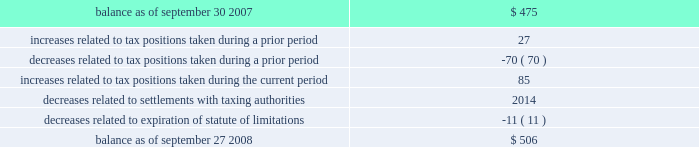Table of contents notes to consolidated financial statements ( continued ) note 5 2014income taxes ( continued ) fin 48 in the first quarter of 2008 , the company adopted fin 48 .
Upon adoption of fin 48 , the company 2019s cumulative effect of a change in accounting principle resulted in an increase to retained earnings of $ 11 million .
The company had historically classified interest and penalties and unrecognized tax benefits as current liabilities .
Beginning with the adoption of fin 48 , the company classifies gross interest and penalties and unrecognized tax benefits that are not expected to result in payment or receipt of cash within one year as non-current liabilities in the consolidated balance sheet .
The total amount of gross unrecognized tax benefits as of the date of adoption of fin 48 was $ 475 million , of which $ 209 million , if recognized , would affect the company 2019s effective tax rate .
As of september 27 , 2008 , the total amount of gross unrecognized tax benefits was $ 506 million , of which $ 253 million , if recognized , would affect the company 2019s effective tax rate .
The company 2019s total gross unrecognized tax benefits are classified as non-current liabilities in the consolidated balance sheet .
The aggregate changes in the balance of gross unrecognized tax benefits , which excludes interest and penalties , for the fiscal year ended september 27 , 2008 , is as follows ( in millions ) : the company 2019s policy to include interest and penalties related to unrecognized tax benefits within the provision for income taxes did not change as a result of adopting fin 48 .
As of the date of adoption , the company had accrued $ 203 million for the gross interest and penalties relating to unrecognized tax benefits .
As of september 27 , 2008 , the total amount of gross interest and penalties accrued was $ 219 million , which is classified as non-current liabilities in the consolidated balance sheet .
In 2008 , the company recognized interest expense in connection with tax matters of $ 16 million .
The company is subject to taxation and files income tax returns in the u.s .
Federal jurisdiction and in many state and foreign jurisdictions .
For u.s .
Federal income tax purposes , all years prior to 2002 are closed .
The years 2002-2003 have been examined by the internal revenue service ( the 201cirs 201d ) and disputed issues have been taken to administrative appeals .
The irs is currently examining the 2004-2006 years .
In addition , the company is also subject to audits by state , local , and foreign tax authorities .
In major states and major foreign jurisdictions , the years subsequent to 1988 and 2000 , respectively , generally remain open and could be subject to examination by the taxing authorities .
Management believes that an adequate provision has been made for any adjustments that may result from tax examinations .
However , the outcome of tax audits cannot be predicted with certainty .
If any issues addressed in the company 2019s tax audits are resolved in a manner not consistent with management 2019s expectations , the company could be required to adjust its provision for income tax in the period such resolution occurs .
Although timing of the resolution and/or closure of audits is highly uncertain , the company does not believe it is reasonably possible that its unrecognized tax benefits would materially change in the next 12 months. .

What is the net of increases related to tax positions taken during a prior period and decreases related to tax positions taken during a prior period , in millions? 
Computations: (27 + -70)
Answer: -43.0. 